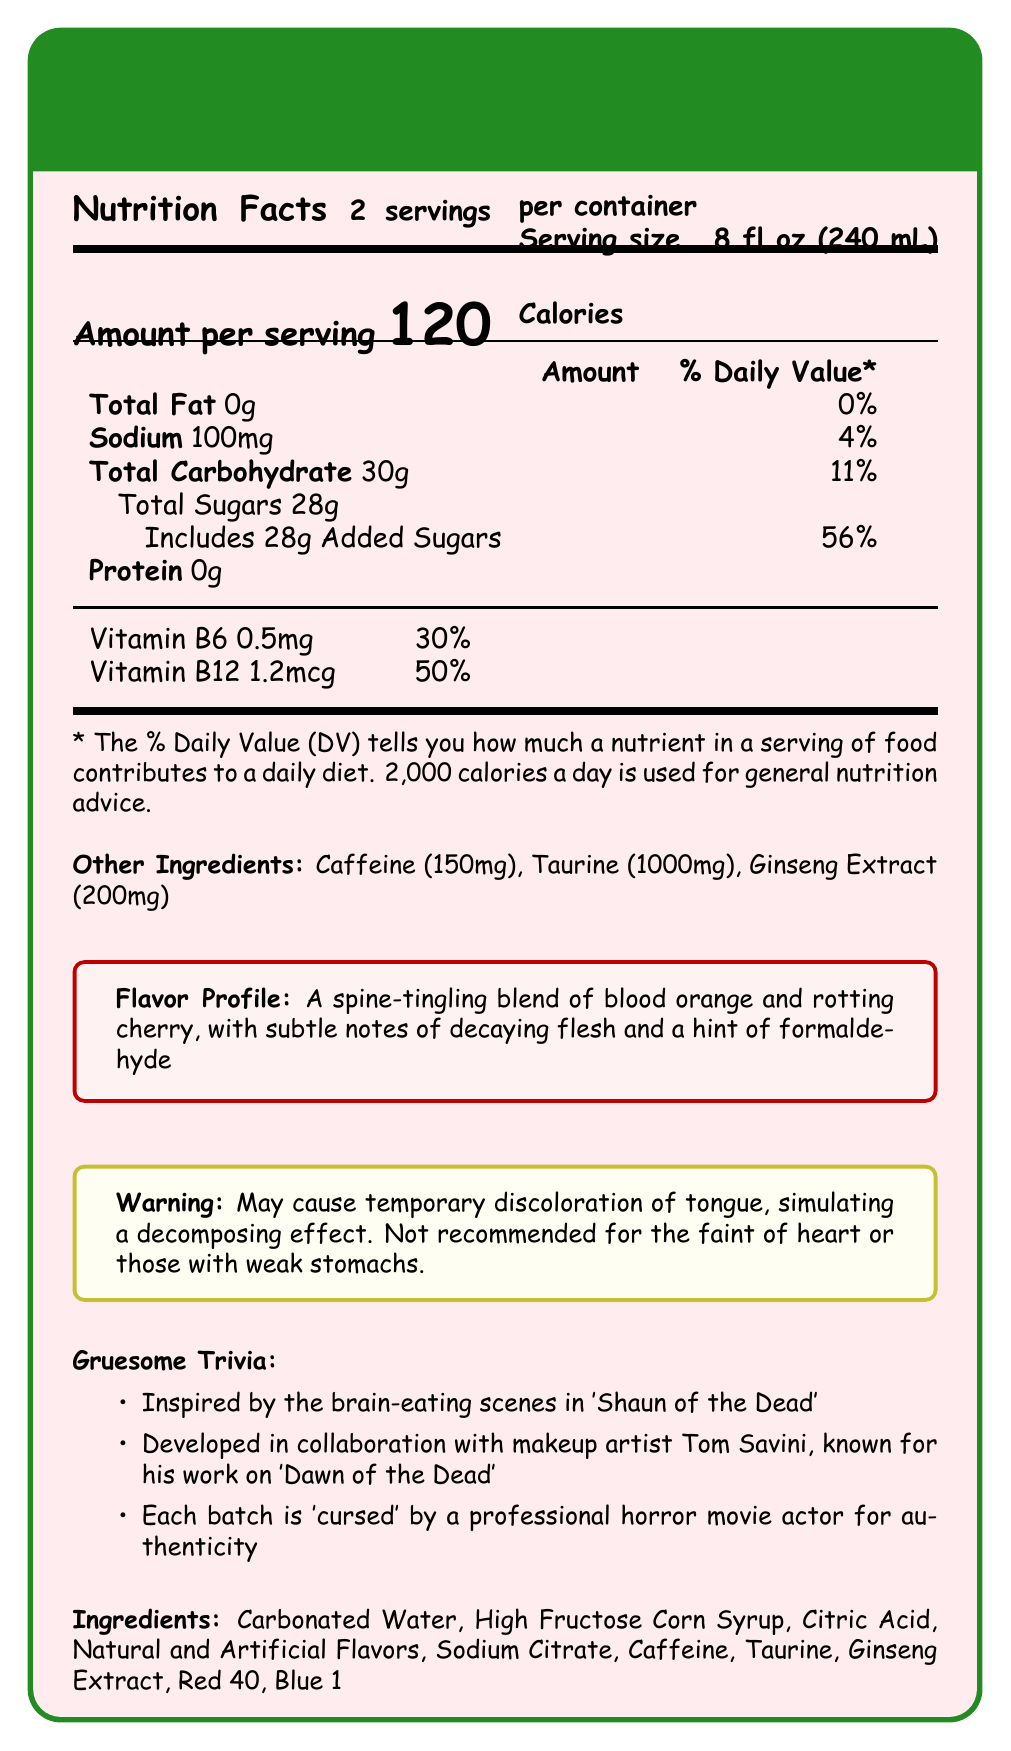what is the serving size for "Zombie Brain Juice Energy Drink"? The document lists the serving size directly under the product name as 8 fl oz (240 mL).
Answer: 8 fl oz (240 mL) how many servings are in each container? The document specifies "2 servings per container" in the Nutrition Facts section.
Answer: 2 how many calories are in one serving of this energy drink? The large text in the Nutrition Facts section clearly states that each serving contains 120 calories.
Answer: 120 what percentage of the Daily Value is the sodium content per serving? The Nutrition Facts table shows that 100mg of sodium provides 4% of the Daily Value.
Answer: 4% list three main ingredients in "Zombie Brain Juice Energy Drink". The ingredient list in the document shows these three ingredients among others.
Answer: Carbonated Water, High Fructose Corn Syrup, Citric Acid which of the following is NOT an ingredient in "Zombie Brain Juice Energy Drink"? A. Sodium Citrate B. Ascorbic Acid C. Red 40 D. Blue 1 Ascorbic Acid is not listed as an ingredient; only Sodium Citrate, Red 40, and Blue 1 are.
Answer: B what is the total amount of carbohydrates per serving? The Nutrition Facts table indicates that the total carbohydrate content per serving is 30g.
Answer: 30g True or False: "Zombie Brain Juice Energy Drink" contains protein. The document states that the protein content is 0g, meaning it contains no protein.
Answer: False how much caffeine is in one serving of the drink? The document lists caffeine (150mg) under Other Ingredients.
Answer: 150mg describe the flavor profile of "Zombie Brain Juice Energy Drink". The flavor profile is provided in the "Flavor Profile" section.
Answer: A spine-tingling blend of blood orange and rotting cherry, with subtle notes of decaying flesh and a hint of formaldehyde what amount of Vitamin B6 is in one serving? The document specifies that one serving contains 0.5mg of Vitamin B6.
Answer: 0.5mg how much added sugar does one serving contain, and what percentage of the Daily Value does this represent? The Nutrition Facts table shows that each serving includes 28g of added sugars, which constitutes 56% of the Daily Value.
Answer: 28g, 56% summarize the main idea of the document. The document is primarily focused on conveying the complete nutritional breakdown, ingredients, and thematic elements of the "Zombie Brain Juice Energy Drink".
Answer: The document provides detailed nutritional information and descriptions of "Zombie Brain Juice Energy Drink", highlighting its unique horror-themed flavor profile, trivia, warning, and ingredients. how much sodium is in both servings combined? Each serving contains 100mg of sodium, so two servings would contain 200mg in total.
Answer: 200mg which trivia fact is associated with makeup artist Tom Savini? A. Inspired by the brain-eating scenes in 'Shaun of the Dead' B. Developed in collaboration with makeup artist Tom Savini, known for his work on 'Dawn of the Dead' C. Each batch is 'cursed' by a professional horror movie actor The document lists Tom Savini as collaborating on the development of the drink and mentions his work on 'Dawn of the Dead'.
Answer: B how is each batch of "Zombie Brain Juice Energy Drink" made authentic? The trivia section of the document states this unique selling point.
Answer: Each batch is 'cursed' by a professional horror movie actor for authenticity how does the drink affect the tongue temporarily? The warning section explains that the drink may cause temporary tongue discoloration.
Answer: May cause temporary discoloration simulating a decomposing effect what is the product's serving size in liters? The document provides the serving size in fluid ounces (8 fl oz) and milliliters (240 mL), but not in liters directly.
Answer: Cannot be determined 